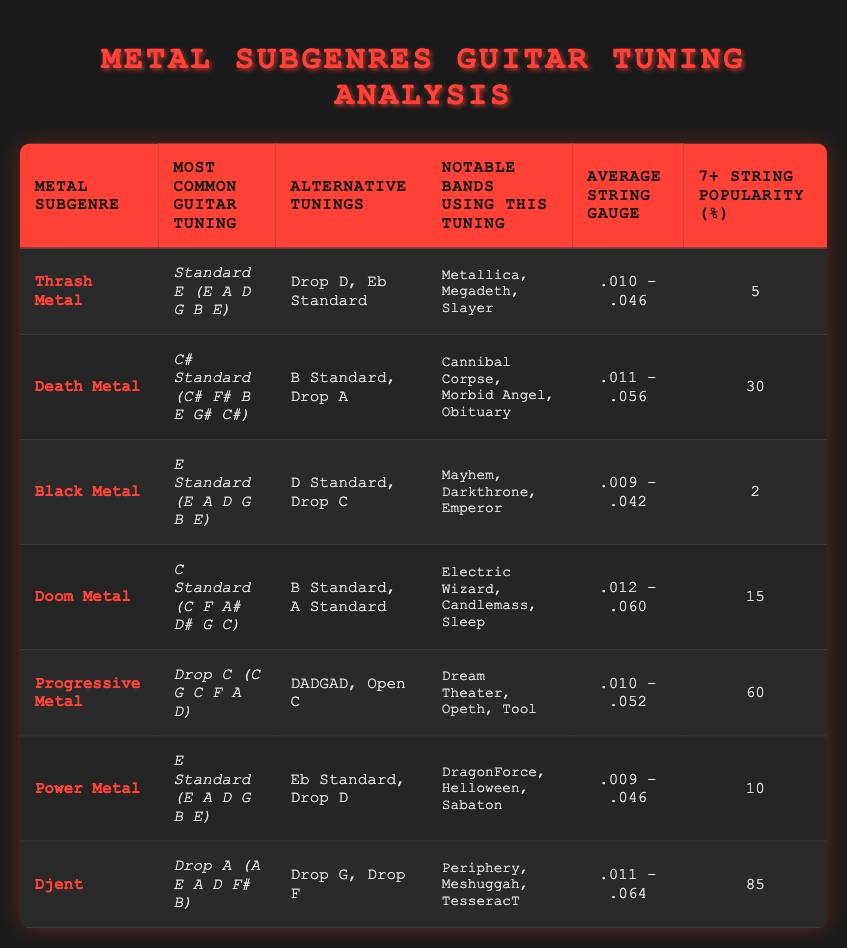What is the most common guitar tuning used in Thrash Metal? The most common guitar tuning for Thrash Metal, according to the table, is Standard E (E A D G B E) as listed in the column for that subgenre.
Answer: Standard E (E A D G B E) Which subgenre has the highest average string gauge? To find which subgenre has the highest average string gauge, we compare the average string gauge of all listed subgenres. The highest is .012 - .060, which belongs to Doom Metal.
Answer: Doom Metal Is Drop A tuning more popular than Drop D tuning in terms of 7+ string popularity? Drop A has a 7+ string popularity of 85%, whereas Drop D (appearing under both Thrash Metal and Power Metal) has a maximum popularity of 10%. Thus, Drop A is indeed more popular than Drop D.
Answer: Yes Which subgenres use E Standard tuning and what are their notable bands? Both Thrash Metal and Power Metal use E Standard tuning. The notable bands for Thrash Metal are Metallica, Megadeth, and Slayer, while for Power Metal, they are DragonForce, Helloween, and Sabaton.
Answer: Thrash Metal: Metallica, Megadeth, Slayer; Power Metal: DragonForce, Helloween, Sabaton What is the average 7+ string popularity percentage across all subgenres? To calculate the average 7+ string popularity percentage, sum all the percentages: 5 + 30 + 2 + 15 + 60 + 10 + 85 = 207. Divide by the number of subgenres (7): 207/7 = 29.57. Thus, the average is roughly 29.6%.
Answer: 29.6% Does Black Metal have a higher 7+ string popularity percentage than Doom Metal? Black Metal has a 7+ string popularity of 2%, while Doom Metal has 15%. Since 15% is greater than 2%, Black Metal does not have a higher popularity percentage than Doom Metal.
Answer: No Which subgenre's tuning features the most notable bands? The subgenre with the most notable bands is Djent, featuring three well-known bands: Periphery, Meshuggah, and TesseracT, according to the data presented in the table.
Answer: Djent How many subgenres use Alternative Tunings besides their Most Common Guitar Tuning? Three subgenres utilize alternative tunings: Thrash Metal, Death Metal, and Progressive Metal. By observing the data, we can see that each of these subgenres has listed at least one alternative tuning in the corresponding column.
Answer: Three 